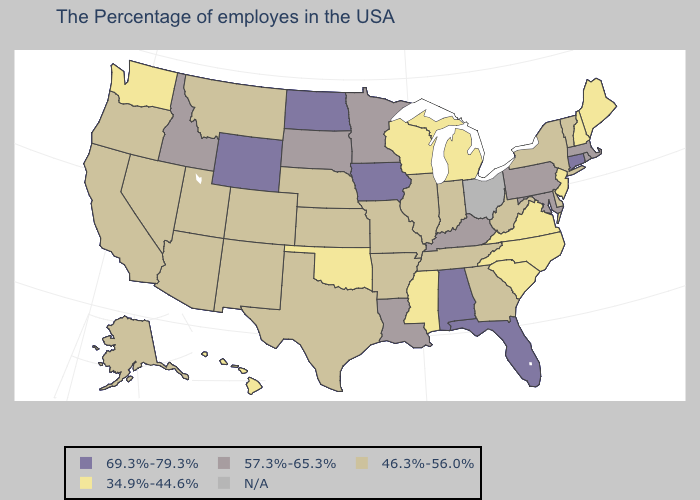Name the states that have a value in the range 46.3%-56.0%?
Be succinct. Vermont, New York, Delaware, West Virginia, Georgia, Indiana, Tennessee, Illinois, Missouri, Arkansas, Kansas, Nebraska, Texas, Colorado, New Mexico, Utah, Montana, Arizona, Nevada, California, Oregon, Alaska. Name the states that have a value in the range 34.9%-44.6%?
Keep it brief. Maine, New Hampshire, New Jersey, Virginia, North Carolina, South Carolina, Michigan, Wisconsin, Mississippi, Oklahoma, Washington, Hawaii. Does Colorado have the lowest value in the West?
Quick response, please. No. Name the states that have a value in the range 57.3%-65.3%?
Keep it brief. Massachusetts, Rhode Island, Maryland, Pennsylvania, Kentucky, Louisiana, Minnesota, South Dakota, Idaho. Is the legend a continuous bar?
Be succinct. No. What is the highest value in the USA?
Be succinct. 69.3%-79.3%. What is the value of Texas?
Short answer required. 46.3%-56.0%. What is the value of Maine?
Keep it brief. 34.9%-44.6%. Name the states that have a value in the range N/A?
Concise answer only. Ohio. Among the states that border North Dakota , which have the highest value?
Short answer required. Minnesota, South Dakota. Name the states that have a value in the range N/A?
Write a very short answer. Ohio. Which states have the highest value in the USA?
Be succinct. Connecticut, Florida, Alabama, Iowa, North Dakota, Wyoming. 